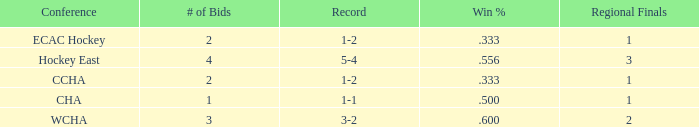What is the average Regional Finals score when the record is 3-2 and there are more than 3 bids? None. 